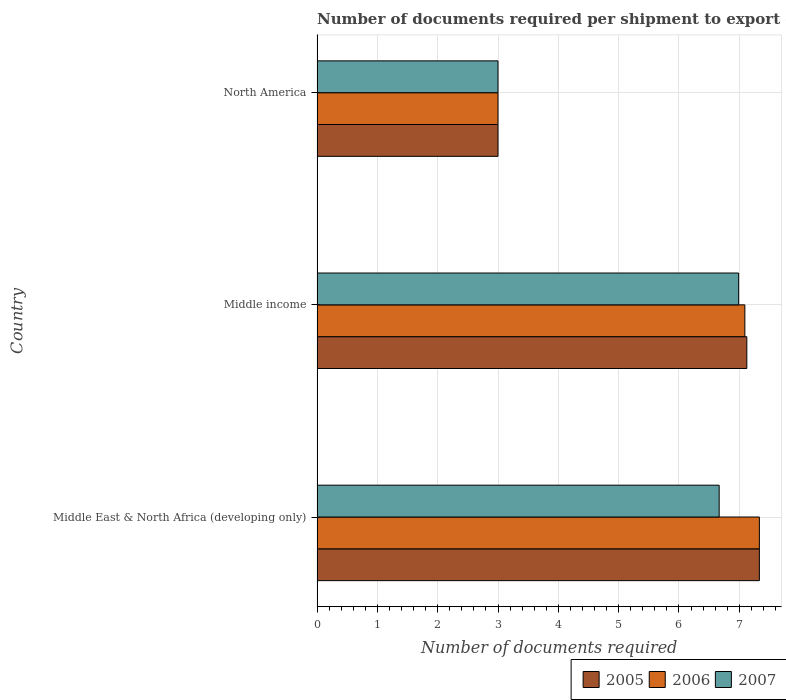How many different coloured bars are there?
Your answer should be compact. 3. Are the number of bars per tick equal to the number of legend labels?
Offer a terse response. Yes. What is the label of the 3rd group of bars from the top?
Provide a short and direct response. Middle East & North Africa (developing only). In how many cases, is the number of bars for a given country not equal to the number of legend labels?
Provide a succinct answer. 0. What is the number of documents required per shipment to export goods in 2006 in Middle income?
Your answer should be compact. 7.09. Across all countries, what is the maximum number of documents required per shipment to export goods in 2005?
Your response must be concise. 7.33. Across all countries, what is the minimum number of documents required per shipment to export goods in 2006?
Provide a succinct answer. 3. In which country was the number of documents required per shipment to export goods in 2005 maximum?
Make the answer very short. Middle East & North Africa (developing only). What is the total number of documents required per shipment to export goods in 2006 in the graph?
Ensure brevity in your answer.  17.43. What is the difference between the number of documents required per shipment to export goods in 2005 in Middle East & North Africa (developing only) and that in North America?
Your response must be concise. 4.33. What is the difference between the number of documents required per shipment to export goods in 2005 in North America and the number of documents required per shipment to export goods in 2006 in Middle East & North Africa (developing only)?
Make the answer very short. -4.33. What is the average number of documents required per shipment to export goods in 2007 per country?
Provide a short and direct response. 5.55. What is the difference between the number of documents required per shipment to export goods in 2007 and number of documents required per shipment to export goods in 2006 in Middle income?
Offer a terse response. -0.1. In how many countries, is the number of documents required per shipment to export goods in 2005 greater than 5.6 ?
Make the answer very short. 2. What is the ratio of the number of documents required per shipment to export goods in 2005 in Middle income to that in North America?
Your answer should be compact. 2.38. Is the difference between the number of documents required per shipment to export goods in 2007 in Middle East & North Africa (developing only) and Middle income greater than the difference between the number of documents required per shipment to export goods in 2006 in Middle East & North Africa (developing only) and Middle income?
Ensure brevity in your answer.  No. What is the difference between the highest and the second highest number of documents required per shipment to export goods in 2007?
Your answer should be compact. 0.32. What is the difference between the highest and the lowest number of documents required per shipment to export goods in 2007?
Offer a very short reply. 3.99. In how many countries, is the number of documents required per shipment to export goods in 2007 greater than the average number of documents required per shipment to export goods in 2007 taken over all countries?
Make the answer very short. 2. Is the sum of the number of documents required per shipment to export goods in 2005 in Middle East & North Africa (developing only) and Middle income greater than the maximum number of documents required per shipment to export goods in 2006 across all countries?
Offer a very short reply. Yes. How many bars are there?
Keep it short and to the point. 9. Are all the bars in the graph horizontal?
Provide a short and direct response. Yes. How many countries are there in the graph?
Your response must be concise. 3. Are the values on the major ticks of X-axis written in scientific E-notation?
Make the answer very short. No. Does the graph contain any zero values?
Give a very brief answer. No. Where does the legend appear in the graph?
Make the answer very short. Bottom right. How many legend labels are there?
Your answer should be compact. 3. What is the title of the graph?
Offer a very short reply. Number of documents required per shipment to export goods. What is the label or title of the X-axis?
Offer a very short reply. Number of documents required. What is the label or title of the Y-axis?
Provide a short and direct response. Country. What is the Number of documents required in 2005 in Middle East & North Africa (developing only)?
Your response must be concise. 7.33. What is the Number of documents required in 2006 in Middle East & North Africa (developing only)?
Provide a succinct answer. 7.33. What is the Number of documents required in 2007 in Middle East & North Africa (developing only)?
Make the answer very short. 6.67. What is the Number of documents required in 2005 in Middle income?
Make the answer very short. 7.12. What is the Number of documents required of 2006 in Middle income?
Offer a terse response. 7.09. What is the Number of documents required in 2007 in Middle income?
Offer a terse response. 6.99. What is the Number of documents required of 2007 in North America?
Provide a short and direct response. 3. Across all countries, what is the maximum Number of documents required in 2005?
Offer a very short reply. 7.33. Across all countries, what is the maximum Number of documents required of 2006?
Your response must be concise. 7.33. Across all countries, what is the maximum Number of documents required of 2007?
Give a very brief answer. 6.99. What is the total Number of documents required of 2005 in the graph?
Keep it short and to the point. 17.46. What is the total Number of documents required in 2006 in the graph?
Provide a short and direct response. 17.43. What is the total Number of documents required of 2007 in the graph?
Offer a terse response. 16.66. What is the difference between the Number of documents required of 2005 in Middle East & North Africa (developing only) and that in Middle income?
Provide a succinct answer. 0.21. What is the difference between the Number of documents required in 2006 in Middle East & North Africa (developing only) and that in Middle income?
Give a very brief answer. 0.24. What is the difference between the Number of documents required in 2007 in Middle East & North Africa (developing only) and that in Middle income?
Provide a short and direct response. -0.32. What is the difference between the Number of documents required in 2005 in Middle East & North Africa (developing only) and that in North America?
Offer a terse response. 4.33. What is the difference between the Number of documents required in 2006 in Middle East & North Africa (developing only) and that in North America?
Offer a very short reply. 4.33. What is the difference between the Number of documents required of 2007 in Middle East & North Africa (developing only) and that in North America?
Ensure brevity in your answer.  3.67. What is the difference between the Number of documents required of 2005 in Middle income and that in North America?
Ensure brevity in your answer.  4.12. What is the difference between the Number of documents required of 2006 in Middle income and that in North America?
Keep it short and to the point. 4.09. What is the difference between the Number of documents required of 2007 in Middle income and that in North America?
Your answer should be very brief. 3.99. What is the difference between the Number of documents required of 2005 in Middle East & North Africa (developing only) and the Number of documents required of 2006 in Middle income?
Keep it short and to the point. 0.24. What is the difference between the Number of documents required of 2005 in Middle East & North Africa (developing only) and the Number of documents required of 2007 in Middle income?
Your response must be concise. 0.34. What is the difference between the Number of documents required of 2006 in Middle East & North Africa (developing only) and the Number of documents required of 2007 in Middle income?
Provide a succinct answer. 0.34. What is the difference between the Number of documents required in 2005 in Middle East & North Africa (developing only) and the Number of documents required in 2006 in North America?
Make the answer very short. 4.33. What is the difference between the Number of documents required in 2005 in Middle East & North Africa (developing only) and the Number of documents required in 2007 in North America?
Offer a terse response. 4.33. What is the difference between the Number of documents required in 2006 in Middle East & North Africa (developing only) and the Number of documents required in 2007 in North America?
Offer a terse response. 4.33. What is the difference between the Number of documents required in 2005 in Middle income and the Number of documents required in 2006 in North America?
Your response must be concise. 4.12. What is the difference between the Number of documents required of 2005 in Middle income and the Number of documents required of 2007 in North America?
Your response must be concise. 4.12. What is the difference between the Number of documents required of 2006 in Middle income and the Number of documents required of 2007 in North America?
Offer a very short reply. 4.09. What is the average Number of documents required of 2005 per country?
Offer a terse response. 5.82. What is the average Number of documents required in 2006 per country?
Offer a terse response. 5.81. What is the average Number of documents required of 2007 per country?
Offer a very short reply. 5.55. What is the difference between the Number of documents required in 2005 and Number of documents required in 2006 in Middle East & North Africa (developing only)?
Your answer should be very brief. 0. What is the difference between the Number of documents required of 2005 and Number of documents required of 2006 in Middle income?
Your answer should be very brief. 0.03. What is the difference between the Number of documents required in 2005 and Number of documents required in 2007 in Middle income?
Provide a short and direct response. 0.14. What is the difference between the Number of documents required of 2006 and Number of documents required of 2007 in Middle income?
Make the answer very short. 0.1. What is the ratio of the Number of documents required in 2005 in Middle East & North Africa (developing only) to that in Middle income?
Your response must be concise. 1.03. What is the ratio of the Number of documents required of 2006 in Middle East & North Africa (developing only) to that in Middle income?
Your answer should be very brief. 1.03. What is the ratio of the Number of documents required in 2007 in Middle East & North Africa (developing only) to that in Middle income?
Offer a very short reply. 0.95. What is the ratio of the Number of documents required in 2005 in Middle East & North Africa (developing only) to that in North America?
Make the answer very short. 2.44. What is the ratio of the Number of documents required of 2006 in Middle East & North Africa (developing only) to that in North America?
Offer a terse response. 2.44. What is the ratio of the Number of documents required in 2007 in Middle East & North Africa (developing only) to that in North America?
Your response must be concise. 2.22. What is the ratio of the Number of documents required in 2005 in Middle income to that in North America?
Offer a very short reply. 2.38. What is the ratio of the Number of documents required of 2006 in Middle income to that in North America?
Your answer should be compact. 2.36. What is the ratio of the Number of documents required in 2007 in Middle income to that in North America?
Give a very brief answer. 2.33. What is the difference between the highest and the second highest Number of documents required of 2005?
Give a very brief answer. 0.21. What is the difference between the highest and the second highest Number of documents required of 2006?
Offer a very short reply. 0.24. What is the difference between the highest and the second highest Number of documents required in 2007?
Your response must be concise. 0.32. What is the difference between the highest and the lowest Number of documents required of 2005?
Ensure brevity in your answer.  4.33. What is the difference between the highest and the lowest Number of documents required of 2006?
Provide a succinct answer. 4.33. What is the difference between the highest and the lowest Number of documents required of 2007?
Your answer should be very brief. 3.99. 